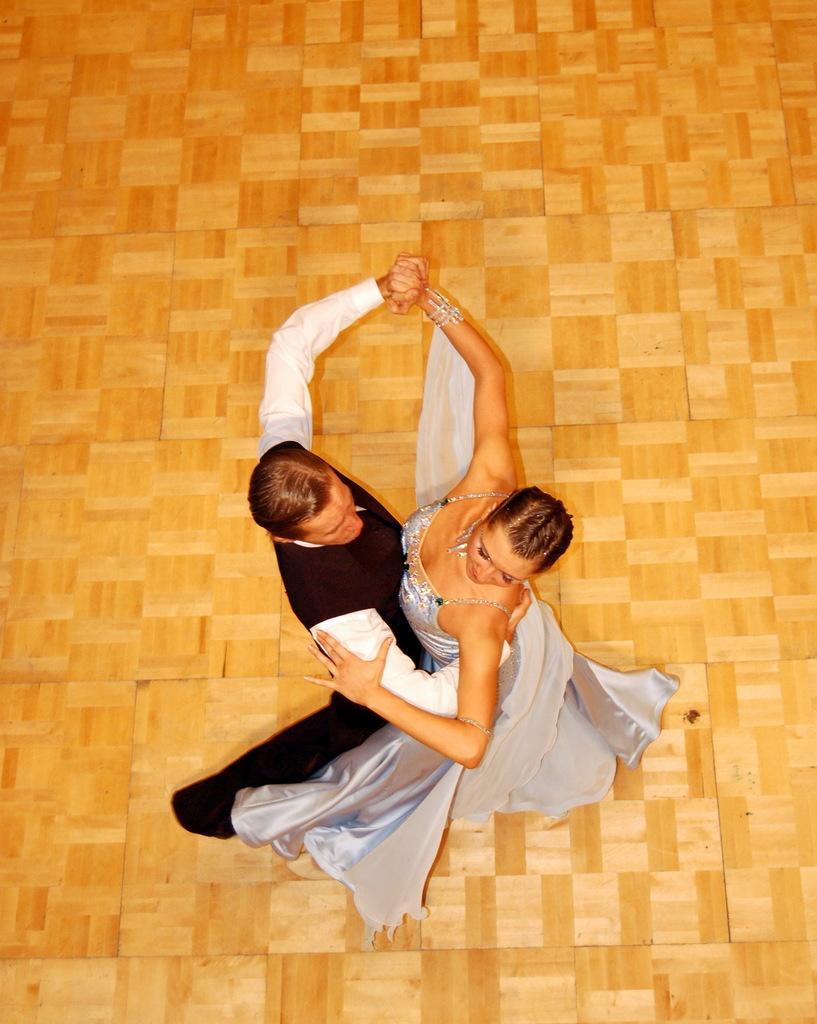Describe this image in one or two sentences. In this picture I can observe a couple dancing on the floor. Man is wearing black and white color dress. The floor is in brown color. 